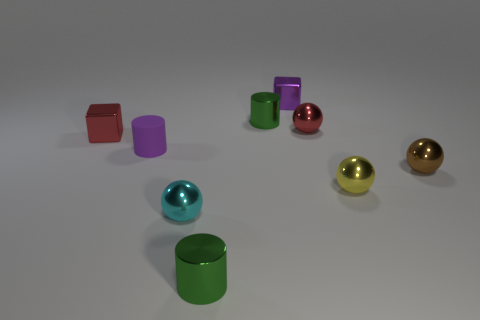Subtract all green cubes. Subtract all yellow spheres. How many cubes are left? 2 Subtract all cylinders. How many objects are left? 6 Subtract 0 blue balls. How many objects are left? 9 Subtract all tiny purple rubber spheres. Subtract all red cubes. How many objects are left? 8 Add 6 small yellow shiny objects. How many small yellow shiny objects are left? 7 Add 2 small purple matte blocks. How many small purple matte blocks exist? 2 